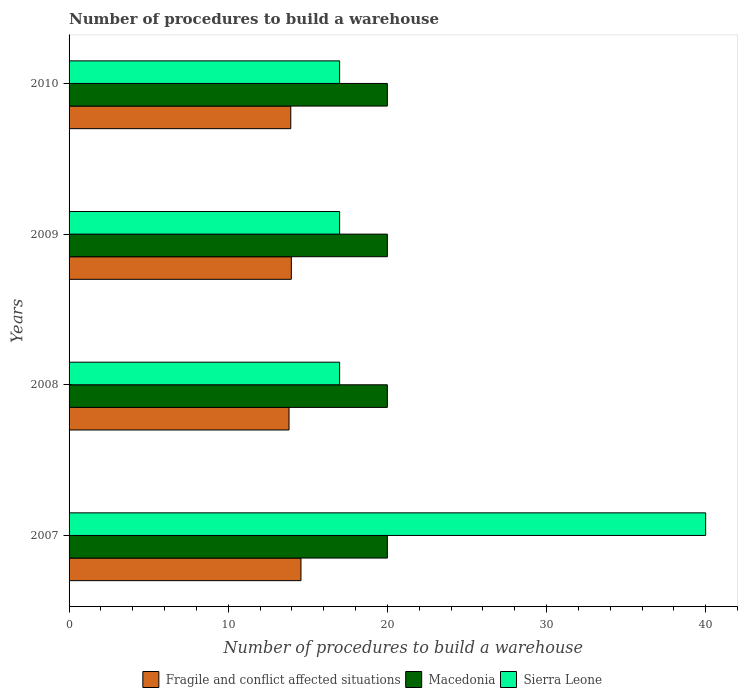How many groups of bars are there?
Make the answer very short. 4. How many bars are there on the 4th tick from the bottom?
Offer a terse response. 3. What is the number of procedures to build a warehouse in in Macedonia in 2009?
Make the answer very short. 20. Across all years, what is the maximum number of procedures to build a warehouse in in Sierra Leone?
Ensure brevity in your answer.  40. Across all years, what is the minimum number of procedures to build a warehouse in in Sierra Leone?
Keep it short and to the point. 17. In which year was the number of procedures to build a warehouse in in Macedonia minimum?
Provide a succinct answer. 2007. What is the total number of procedures to build a warehouse in in Macedonia in the graph?
Provide a succinct answer. 80. What is the difference between the number of procedures to build a warehouse in in Sierra Leone in 2010 and the number of procedures to build a warehouse in in Fragile and conflict affected situations in 2007?
Offer a very short reply. 2.43. What is the average number of procedures to build a warehouse in in Sierra Leone per year?
Offer a very short reply. 22.75. In the year 2010, what is the difference between the number of procedures to build a warehouse in in Sierra Leone and number of procedures to build a warehouse in in Fragile and conflict affected situations?
Give a very brief answer. 3.07. In how many years, is the number of procedures to build a warehouse in in Macedonia greater than 8 ?
Give a very brief answer. 4. What is the ratio of the number of procedures to build a warehouse in in Sierra Leone in 2008 to that in 2010?
Ensure brevity in your answer.  1. Is the number of procedures to build a warehouse in in Fragile and conflict affected situations in 2007 less than that in 2010?
Offer a very short reply. No. Is the difference between the number of procedures to build a warehouse in in Sierra Leone in 2008 and 2010 greater than the difference between the number of procedures to build a warehouse in in Fragile and conflict affected situations in 2008 and 2010?
Your response must be concise. Yes. What is the difference between the highest and the second highest number of procedures to build a warehouse in in Sierra Leone?
Offer a very short reply. 23. What is the difference between the highest and the lowest number of procedures to build a warehouse in in Fragile and conflict affected situations?
Provide a succinct answer. 0.75. In how many years, is the number of procedures to build a warehouse in in Macedonia greater than the average number of procedures to build a warehouse in in Macedonia taken over all years?
Offer a terse response. 0. Is the sum of the number of procedures to build a warehouse in in Sierra Leone in 2008 and 2009 greater than the maximum number of procedures to build a warehouse in in Fragile and conflict affected situations across all years?
Your answer should be compact. Yes. What does the 3rd bar from the top in 2007 represents?
Ensure brevity in your answer.  Fragile and conflict affected situations. What does the 2nd bar from the bottom in 2007 represents?
Give a very brief answer. Macedonia. Are all the bars in the graph horizontal?
Offer a very short reply. Yes. How many years are there in the graph?
Give a very brief answer. 4. Are the values on the major ticks of X-axis written in scientific E-notation?
Ensure brevity in your answer.  No. Does the graph contain any zero values?
Offer a very short reply. No. What is the title of the graph?
Keep it short and to the point. Number of procedures to build a warehouse. Does "Gabon" appear as one of the legend labels in the graph?
Provide a succinct answer. No. What is the label or title of the X-axis?
Your response must be concise. Number of procedures to build a warehouse. What is the label or title of the Y-axis?
Your response must be concise. Years. What is the Number of procedures to build a warehouse in Fragile and conflict affected situations in 2007?
Keep it short and to the point. 14.57. What is the Number of procedures to build a warehouse in Macedonia in 2007?
Your response must be concise. 20. What is the Number of procedures to build a warehouse of Fragile and conflict affected situations in 2008?
Make the answer very short. 13.82. What is the Number of procedures to build a warehouse of Fragile and conflict affected situations in 2009?
Make the answer very short. 13.97. What is the Number of procedures to build a warehouse in Macedonia in 2009?
Provide a succinct answer. 20. What is the Number of procedures to build a warehouse in Fragile and conflict affected situations in 2010?
Your answer should be very brief. 13.93. What is the Number of procedures to build a warehouse of Macedonia in 2010?
Offer a terse response. 20. Across all years, what is the maximum Number of procedures to build a warehouse in Fragile and conflict affected situations?
Offer a very short reply. 14.57. Across all years, what is the maximum Number of procedures to build a warehouse in Sierra Leone?
Ensure brevity in your answer.  40. Across all years, what is the minimum Number of procedures to build a warehouse of Fragile and conflict affected situations?
Give a very brief answer. 13.82. Across all years, what is the minimum Number of procedures to build a warehouse in Sierra Leone?
Offer a terse response. 17. What is the total Number of procedures to build a warehouse of Fragile and conflict affected situations in the graph?
Ensure brevity in your answer.  56.29. What is the total Number of procedures to build a warehouse of Macedonia in the graph?
Offer a very short reply. 80. What is the total Number of procedures to build a warehouse of Sierra Leone in the graph?
Your response must be concise. 91. What is the difference between the Number of procedures to build a warehouse of Fragile and conflict affected situations in 2007 and that in 2008?
Your answer should be compact. 0.75. What is the difference between the Number of procedures to build a warehouse of Sierra Leone in 2007 and that in 2008?
Provide a succinct answer. 23. What is the difference between the Number of procedures to build a warehouse of Fragile and conflict affected situations in 2007 and that in 2009?
Keep it short and to the point. 0.61. What is the difference between the Number of procedures to build a warehouse in Sierra Leone in 2007 and that in 2009?
Provide a short and direct response. 23. What is the difference between the Number of procedures to build a warehouse of Fragile and conflict affected situations in 2007 and that in 2010?
Offer a very short reply. 0.64. What is the difference between the Number of procedures to build a warehouse in Fragile and conflict affected situations in 2008 and that in 2009?
Your answer should be very brief. -0.14. What is the difference between the Number of procedures to build a warehouse of Macedonia in 2008 and that in 2009?
Your answer should be compact. 0. What is the difference between the Number of procedures to build a warehouse of Fragile and conflict affected situations in 2008 and that in 2010?
Ensure brevity in your answer.  -0.11. What is the difference between the Number of procedures to build a warehouse of Sierra Leone in 2008 and that in 2010?
Provide a succinct answer. 0. What is the difference between the Number of procedures to build a warehouse in Fragile and conflict affected situations in 2009 and that in 2010?
Offer a terse response. 0.03. What is the difference between the Number of procedures to build a warehouse in Sierra Leone in 2009 and that in 2010?
Your answer should be compact. 0. What is the difference between the Number of procedures to build a warehouse of Fragile and conflict affected situations in 2007 and the Number of procedures to build a warehouse of Macedonia in 2008?
Offer a very short reply. -5.43. What is the difference between the Number of procedures to build a warehouse in Fragile and conflict affected situations in 2007 and the Number of procedures to build a warehouse in Sierra Leone in 2008?
Make the answer very short. -2.43. What is the difference between the Number of procedures to build a warehouse of Fragile and conflict affected situations in 2007 and the Number of procedures to build a warehouse of Macedonia in 2009?
Your answer should be compact. -5.43. What is the difference between the Number of procedures to build a warehouse in Fragile and conflict affected situations in 2007 and the Number of procedures to build a warehouse in Sierra Leone in 2009?
Provide a short and direct response. -2.43. What is the difference between the Number of procedures to build a warehouse of Fragile and conflict affected situations in 2007 and the Number of procedures to build a warehouse of Macedonia in 2010?
Give a very brief answer. -5.43. What is the difference between the Number of procedures to build a warehouse in Fragile and conflict affected situations in 2007 and the Number of procedures to build a warehouse in Sierra Leone in 2010?
Your answer should be compact. -2.43. What is the difference between the Number of procedures to build a warehouse of Fragile and conflict affected situations in 2008 and the Number of procedures to build a warehouse of Macedonia in 2009?
Keep it short and to the point. -6.18. What is the difference between the Number of procedures to build a warehouse in Fragile and conflict affected situations in 2008 and the Number of procedures to build a warehouse in Sierra Leone in 2009?
Your answer should be very brief. -3.18. What is the difference between the Number of procedures to build a warehouse of Macedonia in 2008 and the Number of procedures to build a warehouse of Sierra Leone in 2009?
Your answer should be very brief. 3. What is the difference between the Number of procedures to build a warehouse of Fragile and conflict affected situations in 2008 and the Number of procedures to build a warehouse of Macedonia in 2010?
Ensure brevity in your answer.  -6.18. What is the difference between the Number of procedures to build a warehouse of Fragile and conflict affected situations in 2008 and the Number of procedures to build a warehouse of Sierra Leone in 2010?
Your answer should be very brief. -3.18. What is the difference between the Number of procedures to build a warehouse in Macedonia in 2008 and the Number of procedures to build a warehouse in Sierra Leone in 2010?
Give a very brief answer. 3. What is the difference between the Number of procedures to build a warehouse in Fragile and conflict affected situations in 2009 and the Number of procedures to build a warehouse in Macedonia in 2010?
Offer a very short reply. -6.03. What is the difference between the Number of procedures to build a warehouse of Fragile and conflict affected situations in 2009 and the Number of procedures to build a warehouse of Sierra Leone in 2010?
Provide a short and direct response. -3.03. What is the difference between the Number of procedures to build a warehouse in Macedonia in 2009 and the Number of procedures to build a warehouse in Sierra Leone in 2010?
Ensure brevity in your answer.  3. What is the average Number of procedures to build a warehouse of Fragile and conflict affected situations per year?
Keep it short and to the point. 14.07. What is the average Number of procedures to build a warehouse in Macedonia per year?
Make the answer very short. 20. What is the average Number of procedures to build a warehouse of Sierra Leone per year?
Provide a succinct answer. 22.75. In the year 2007, what is the difference between the Number of procedures to build a warehouse of Fragile and conflict affected situations and Number of procedures to build a warehouse of Macedonia?
Keep it short and to the point. -5.43. In the year 2007, what is the difference between the Number of procedures to build a warehouse in Fragile and conflict affected situations and Number of procedures to build a warehouse in Sierra Leone?
Your answer should be very brief. -25.43. In the year 2008, what is the difference between the Number of procedures to build a warehouse of Fragile and conflict affected situations and Number of procedures to build a warehouse of Macedonia?
Offer a very short reply. -6.18. In the year 2008, what is the difference between the Number of procedures to build a warehouse of Fragile and conflict affected situations and Number of procedures to build a warehouse of Sierra Leone?
Offer a very short reply. -3.18. In the year 2009, what is the difference between the Number of procedures to build a warehouse of Fragile and conflict affected situations and Number of procedures to build a warehouse of Macedonia?
Your answer should be compact. -6.03. In the year 2009, what is the difference between the Number of procedures to build a warehouse in Fragile and conflict affected situations and Number of procedures to build a warehouse in Sierra Leone?
Offer a very short reply. -3.03. In the year 2009, what is the difference between the Number of procedures to build a warehouse of Macedonia and Number of procedures to build a warehouse of Sierra Leone?
Make the answer very short. 3. In the year 2010, what is the difference between the Number of procedures to build a warehouse in Fragile and conflict affected situations and Number of procedures to build a warehouse in Macedonia?
Your response must be concise. -6.07. In the year 2010, what is the difference between the Number of procedures to build a warehouse in Fragile and conflict affected situations and Number of procedures to build a warehouse in Sierra Leone?
Ensure brevity in your answer.  -3.07. In the year 2010, what is the difference between the Number of procedures to build a warehouse in Macedonia and Number of procedures to build a warehouse in Sierra Leone?
Ensure brevity in your answer.  3. What is the ratio of the Number of procedures to build a warehouse of Fragile and conflict affected situations in 2007 to that in 2008?
Give a very brief answer. 1.05. What is the ratio of the Number of procedures to build a warehouse of Macedonia in 2007 to that in 2008?
Offer a very short reply. 1. What is the ratio of the Number of procedures to build a warehouse in Sierra Leone in 2007 to that in 2008?
Make the answer very short. 2.35. What is the ratio of the Number of procedures to build a warehouse of Fragile and conflict affected situations in 2007 to that in 2009?
Your answer should be very brief. 1.04. What is the ratio of the Number of procedures to build a warehouse of Sierra Leone in 2007 to that in 2009?
Your answer should be compact. 2.35. What is the ratio of the Number of procedures to build a warehouse of Fragile and conflict affected situations in 2007 to that in 2010?
Ensure brevity in your answer.  1.05. What is the ratio of the Number of procedures to build a warehouse in Macedonia in 2007 to that in 2010?
Your response must be concise. 1. What is the ratio of the Number of procedures to build a warehouse in Sierra Leone in 2007 to that in 2010?
Provide a succinct answer. 2.35. What is the ratio of the Number of procedures to build a warehouse of Fragile and conflict affected situations in 2008 to that in 2009?
Your answer should be very brief. 0.99. What is the ratio of the Number of procedures to build a warehouse of Macedonia in 2008 to that in 2009?
Provide a short and direct response. 1. What is the ratio of the Number of procedures to build a warehouse of Sierra Leone in 2008 to that in 2009?
Offer a terse response. 1. What is the ratio of the Number of procedures to build a warehouse of Sierra Leone in 2009 to that in 2010?
Keep it short and to the point. 1. What is the difference between the highest and the second highest Number of procedures to build a warehouse of Fragile and conflict affected situations?
Your answer should be very brief. 0.61. What is the difference between the highest and the second highest Number of procedures to build a warehouse of Macedonia?
Your response must be concise. 0. What is the difference between the highest and the second highest Number of procedures to build a warehouse in Sierra Leone?
Provide a short and direct response. 23. What is the difference between the highest and the lowest Number of procedures to build a warehouse of Macedonia?
Ensure brevity in your answer.  0. 